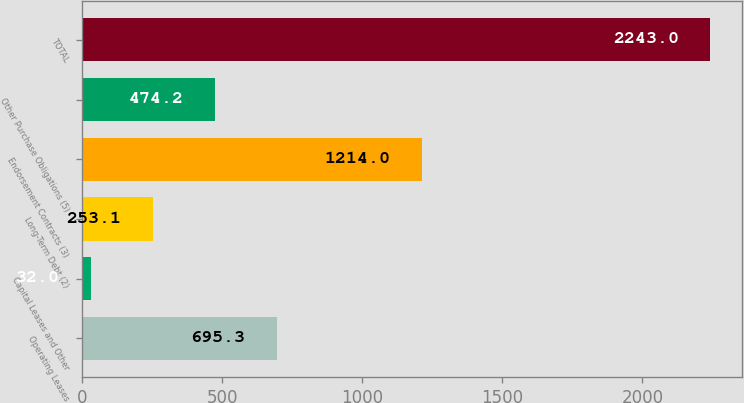Convert chart. <chart><loc_0><loc_0><loc_500><loc_500><bar_chart><fcel>Operating Leases<fcel>Capital Leases and Other<fcel>Long-Term Debt (2)<fcel>Endorsement Contracts (3)<fcel>Other Purchase Obligations (5)<fcel>TOTAL<nl><fcel>695.3<fcel>32<fcel>253.1<fcel>1214<fcel>474.2<fcel>2243<nl></chart> 